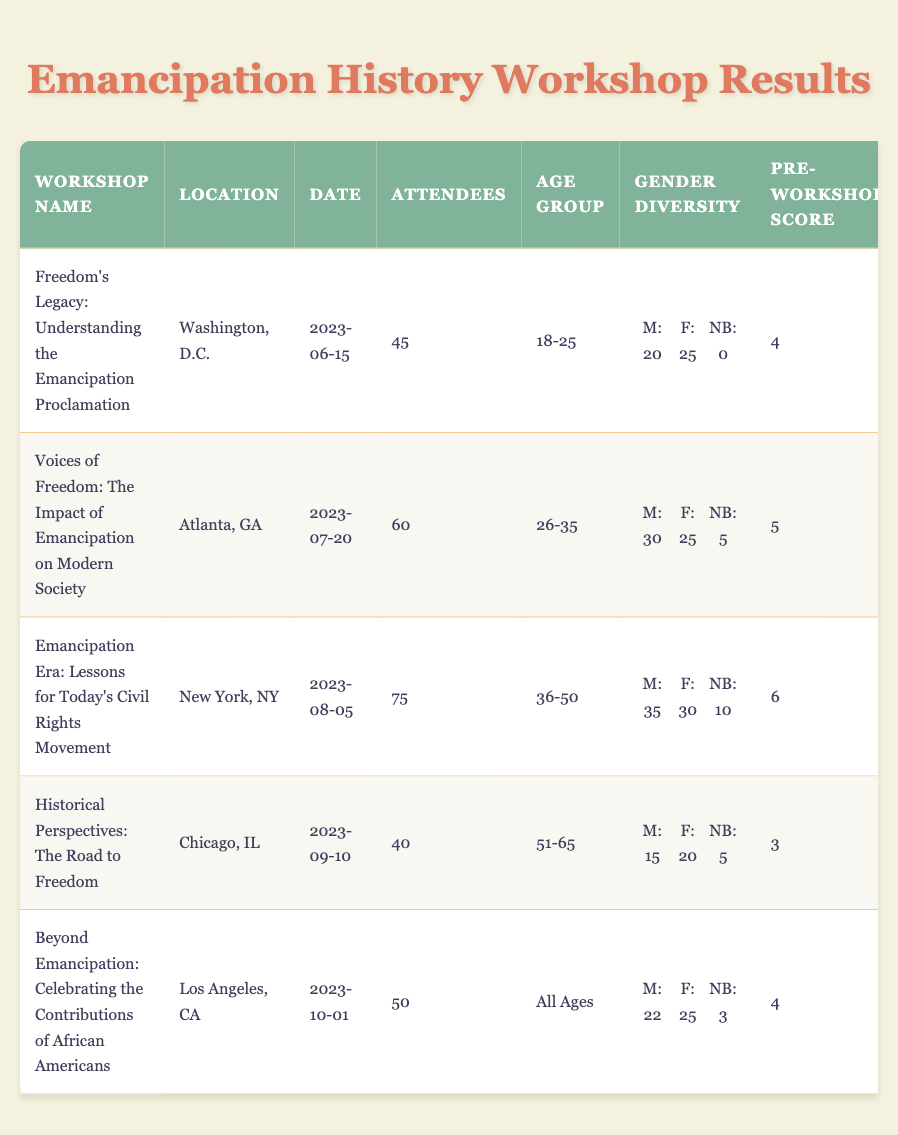What is the location of the "Emancipation Era: Lessons for Today's Civil Rights Movement" workshop? The table specifies that the location of this particular workshop is New York, NY.
Answer: New York, NY How many attendees were there at the "Voices of Freedom: The Impact of Emancipation on Modern Society" workshop? The workshop details indicate there were 60 attendees at this event.
Answer: 60 What was the satisfaction rating for the "Freedom's Legacy: Understanding the Emancipation Proclamation"? According to the table, the satisfaction rating for this workshop was 9 out of 10.
Answer: 9 What is the age group of attendees for the "Historical Perspectives: The Road to Freedom"? The table shows that the age group for this workshop was 51-65 years.
Answer: 51-65 Which workshop had the highest post-workshop knowledge score? The highest post-workshop knowledge score was 10 from the "Emancipation Era: Lessons for Today's Civil Rights Movement."
Answer: 10 Calculate the average pre-workshop knowledge score across all workshops. The pre-workshop scores are 4, 5, 6, 3, and 4. Summing these (4 + 5 + 6 + 3 + 4) gives 22, divided by 5 workshops, results in an average of 4.4.
Answer: 4.4 How many attendees aged 18-25 were there at all workshops combined? The relevant workshop "Freedom's Legacy" had 45 attendees, with 20 of them in the age group 18-25, while no other workshops specifically mentioned this age group. Thus, the total is just 45.
Answer: 45 Did the "Beyond Emancipation" workshop have more male or female attendees? It had 22 male attendees versus 25 female attendees, indicating a higher number of female attendees.
Answer: Female attendees What was the total follow-up involvement in education after the "Emancipation Era: Lessons for Today's Civil Rights Movement"? The table lists that there were 25 participants following up with an involvement in education from this workshop.
Answer: 25 Which workshop had more attendees: "Historical Perspectives" or "Freedom's Legacy"? The "Freedom's Legacy" workshop had 45 attendees while "Historical Perspectives" had 40 attendees, thus, Freedom's Legacy had more.
Answer: Freedom's Legacy How many total volunteers were involved after the "Voices of Freedom" workshop? The table shows that there were 15 volunteers involved after this workshop.
Answer: 15 What is the gender diversity breakdown for the "Beyond Emancipation" workshop? The workshop had 22 males, 25 females, and 3 non-binary attendees, making the total breakdown: M: 22, F: 25, NB: 3.
Answer: M: 22, F: 25, NB: 3 What was the improvement in knowledge scores for the "Historical Perspectives: The Road to Freedom"? The pre-workshop score was 3 and the post-workshop score was 7, showing an improvement of 4 points.
Answer: 4 points Identify the workshop that had the least post-workshop knowledge score. "Historical Perspectives" had a post-workshop score of 7, which is the lowest compared to the others.
Answer: 7 Calculate the total number of attendees across all workshops. The total is 45 + 60 + 75 + 40 + 50, equaling 270 attendees across all workshops.
Answer: 270 How many participants from the "Emancipation Era" workshop were involved in advocacy after the workshop? The follow-up involvement in advocacy from this workshop indicated there were 30 participants involved.
Answer: 30 